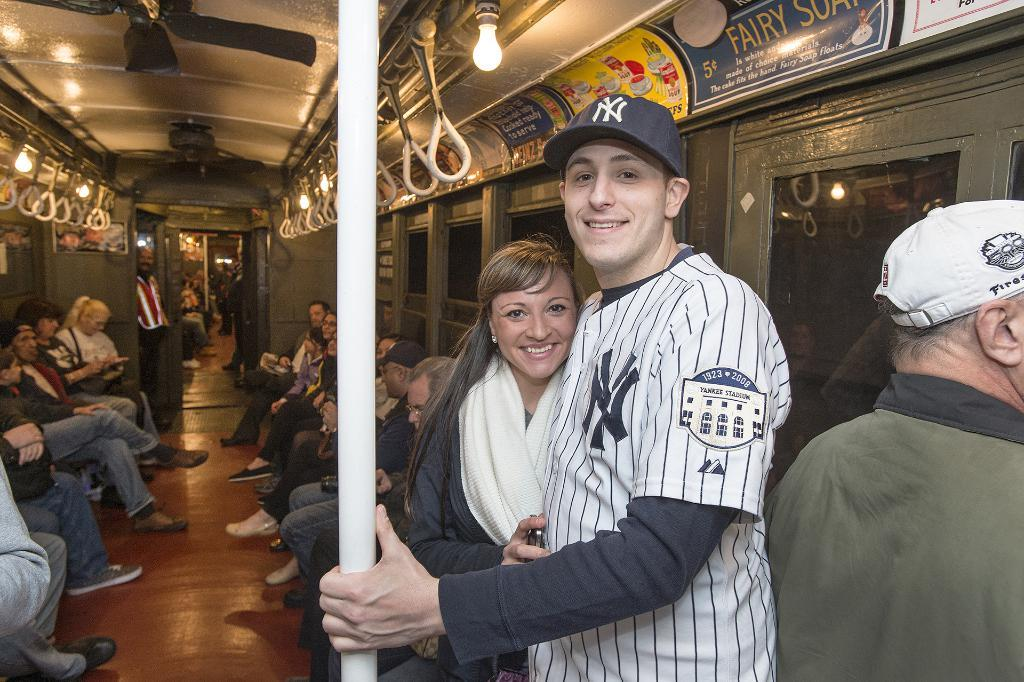<image>
Offer a succinct explanation of the picture presented. a couple on a bus with one wearing a NY Yankees jersey 